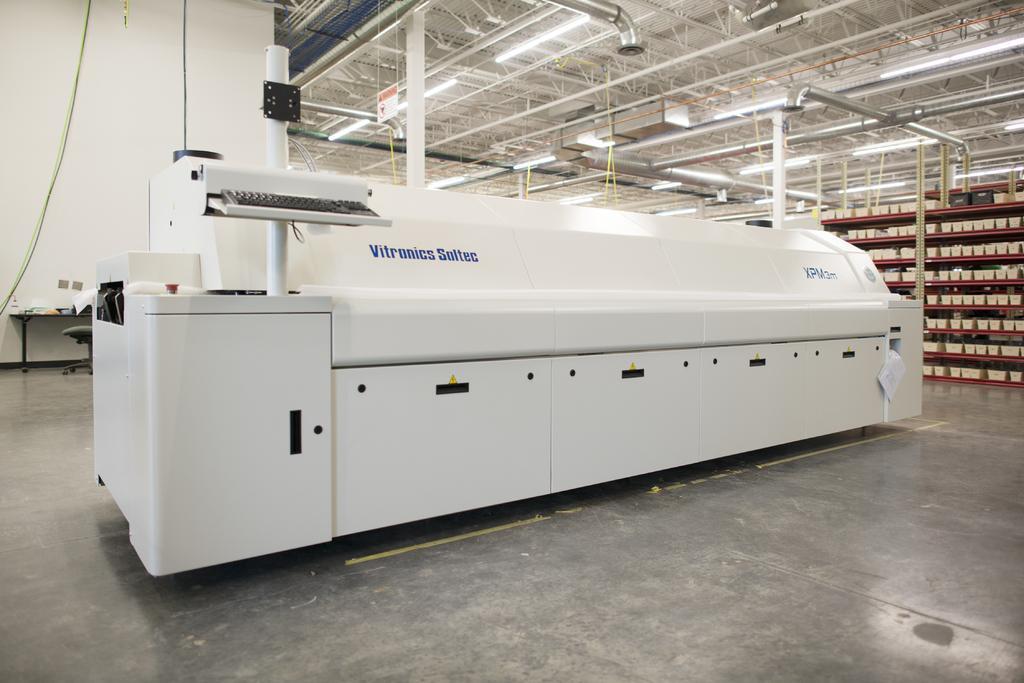Could you give a brief overview of what you see in this image? In the picture we can see an inside view of the factory with some white color machine on it and on it we can see some pipes and a keyboard and behind it, we can see a ceiling with some poles and iron rods and lights and on the floor, we can see the racks in it we can see some things are placed, and in the background we can see a wall and table near it on the floor. 